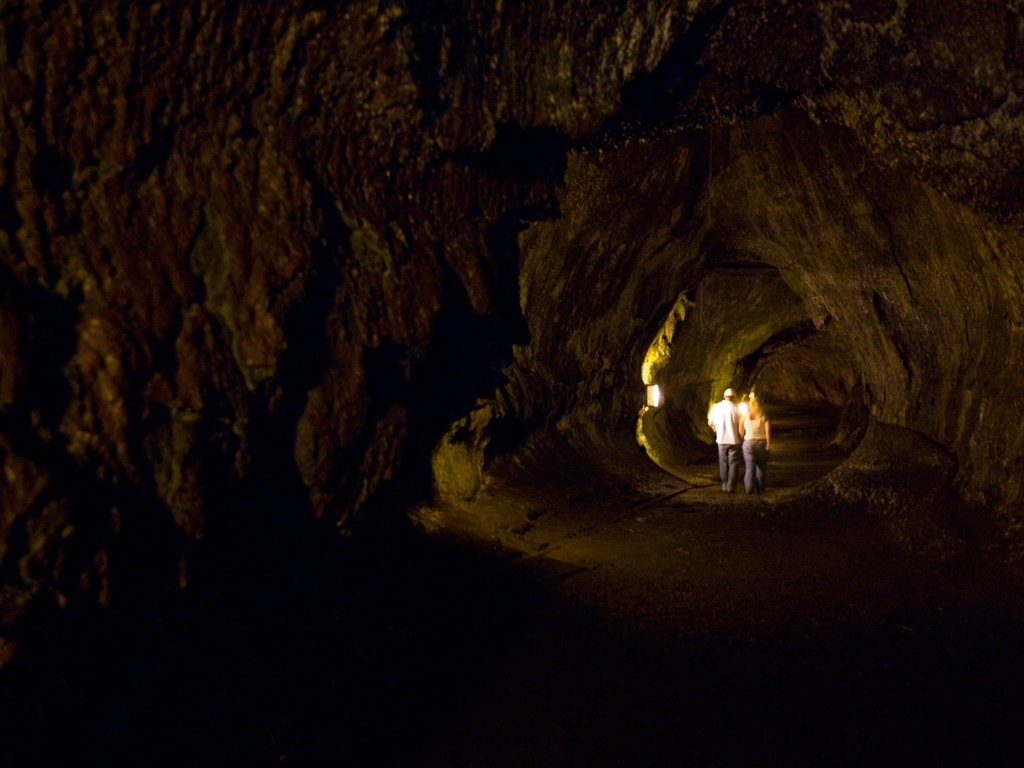What might be the temperature like in this place? The image suggests an underground setting, which typically maintains a cool and stable temperature. It's likely that this enclosed space is cooler than the outside environment, and the individuals present may feel a significant drop in temperature as they move further into the depths. 